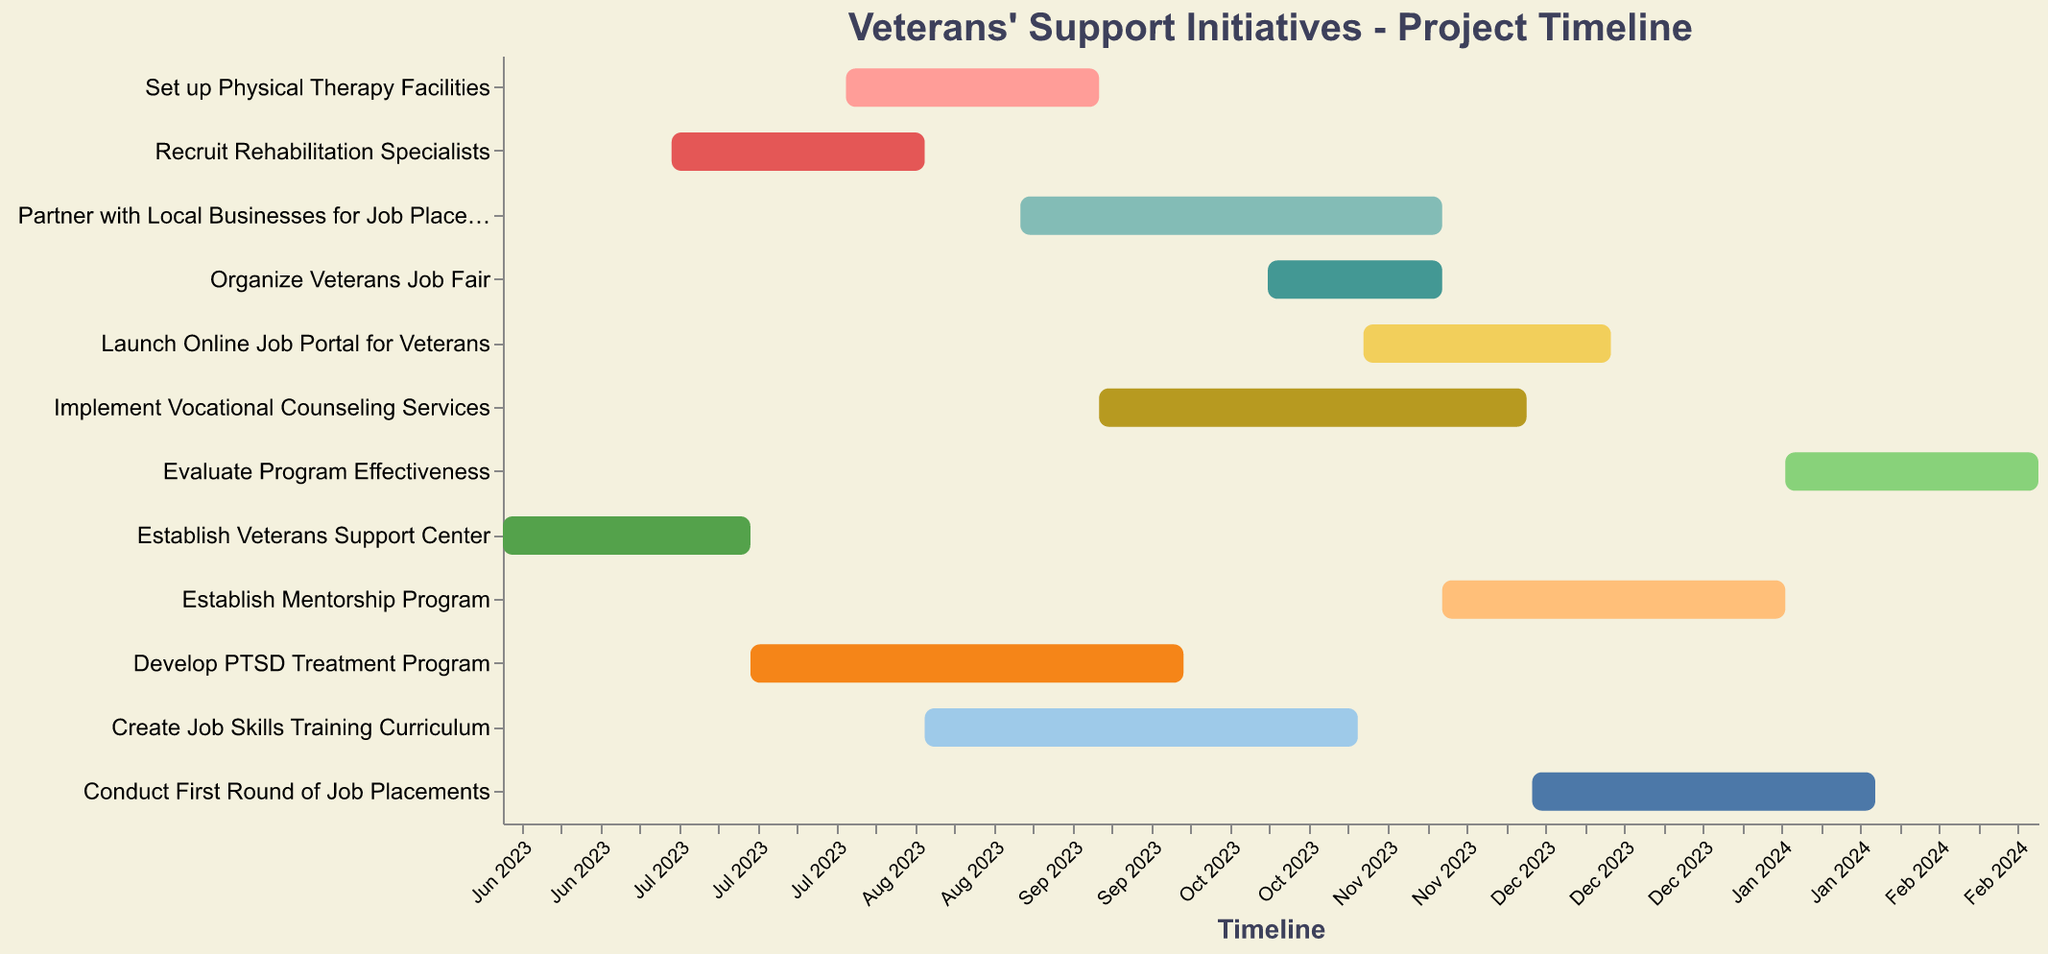What is the title of the chart? The title of the chart is located at the top of the figure. It is prominently displayed and should be easily readable.
Answer: Veterans' Support Initiatives - Project Timeline How many tasks are shown in the Gantt chart? To find the number of tasks, count the distinct task labels along the y-axis of the chart.
Answer: 12 Which task has the longest duration? Identify the task with the longest horizontal bar on the Gantt chart. This represents the longest duration.
Answer: Develop PTSD Treatment Program Which task ends first? Look at the "End Date" for each task and identify the earliest date.
Answer: Establish Veterans Support Center How many tasks overlap in September 2023? Review the timeline section corresponding to September 2023 and count the tasks that have bars extending into this period.
Answer: 5 What is the total duration of the tasks "Create Job Skills Training Curriculum" and "Establish Mentorship Program"? Find the duration for each task from the chart (78 days and 62 days), then sum them up.
Answer: 140 days Which tasks start in November 2023? Check the "Start Date" for each task and identify the ones that start in November 2023.
Answer: Launch Online Job Portal for Veterans, Establish Mentorship Program Which task has a shorter duration: "Recruit Rehabilitation Specialists" or "Set up Physical Therapy Facilities"? Compare the duration of the two tasks (46 days and 46 days).
Answer: Both have the same duration How many days does the "Organize Veterans Job Fair" task last? Look at the duration labeled for the "Organize Veterans Job Fair" task.
Answer: 32 days Do any tasks start in June 2023? If so, which ones? Check the "Start Date" for each task and identify tasks starting in June 2023.
Answer: Establish Veterans Support Center 